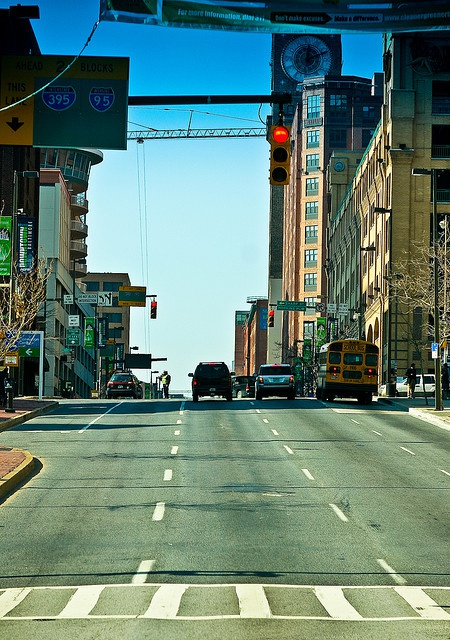Describe the objects in this image and their specific colors. I can see bus in gray, black, maroon, and olive tones, clock in gray, black, navy, blue, and teal tones, car in gray, black, white, and teal tones, traffic light in gray, black, maroon, olive, and red tones, and car in gray, black, and teal tones in this image. 